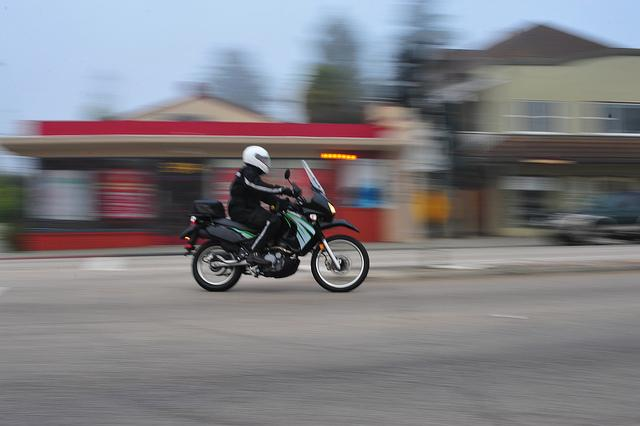Why is the man wearing a white helmet? Please explain your reasoning. protection. The man wants to protect his head. 